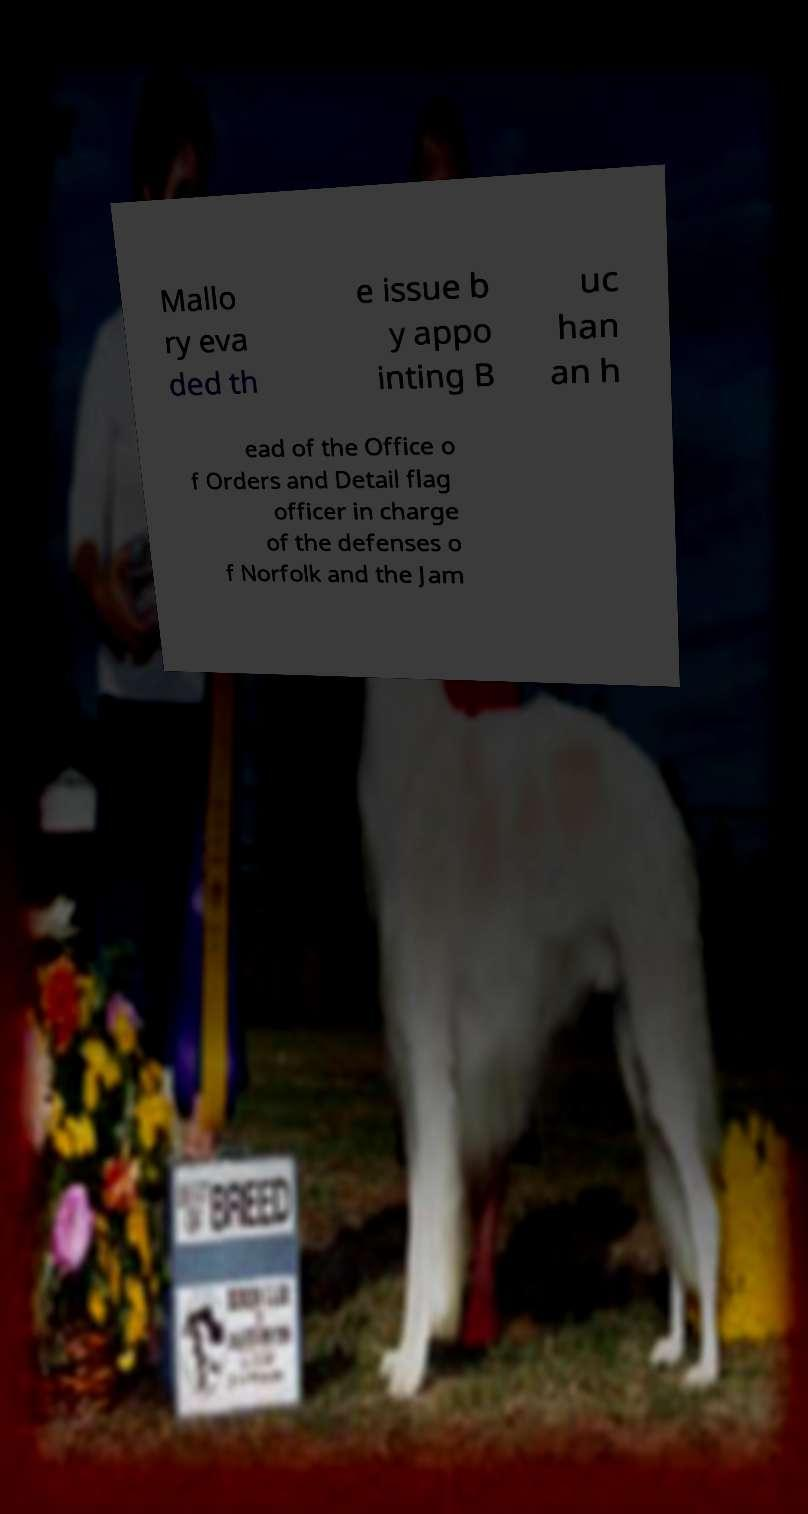Could you extract and type out the text from this image? Mallo ry eva ded th e issue b y appo inting B uc han an h ead of the Office o f Orders and Detail flag officer in charge of the defenses o f Norfolk and the Jam 